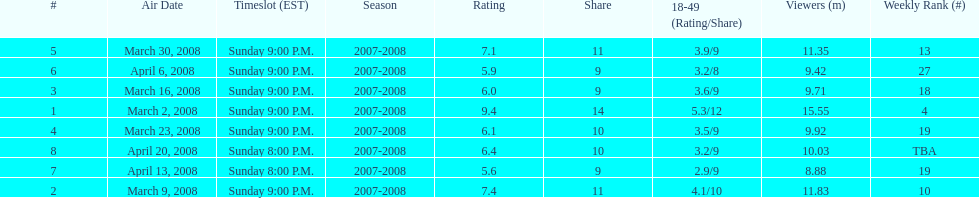What episode had the highest rating? March 2, 2008. 